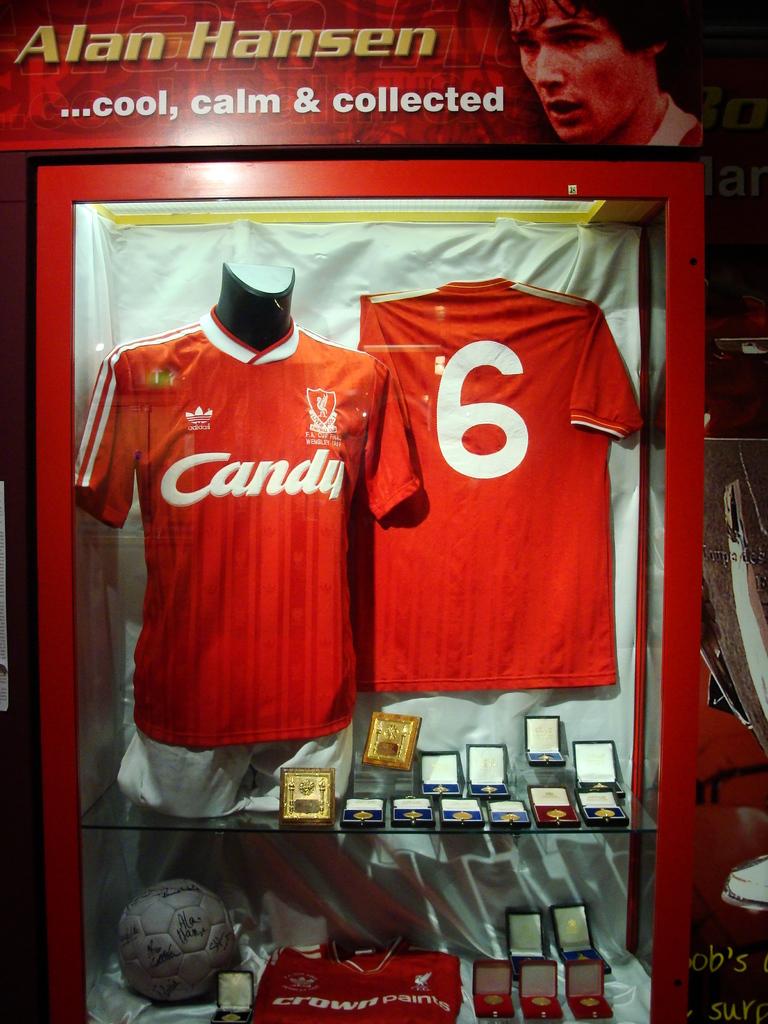What is the number on the back of the shirt?
Provide a succinct answer. 6. What is the persons name at the top?
Give a very brief answer. Alan hansen. 